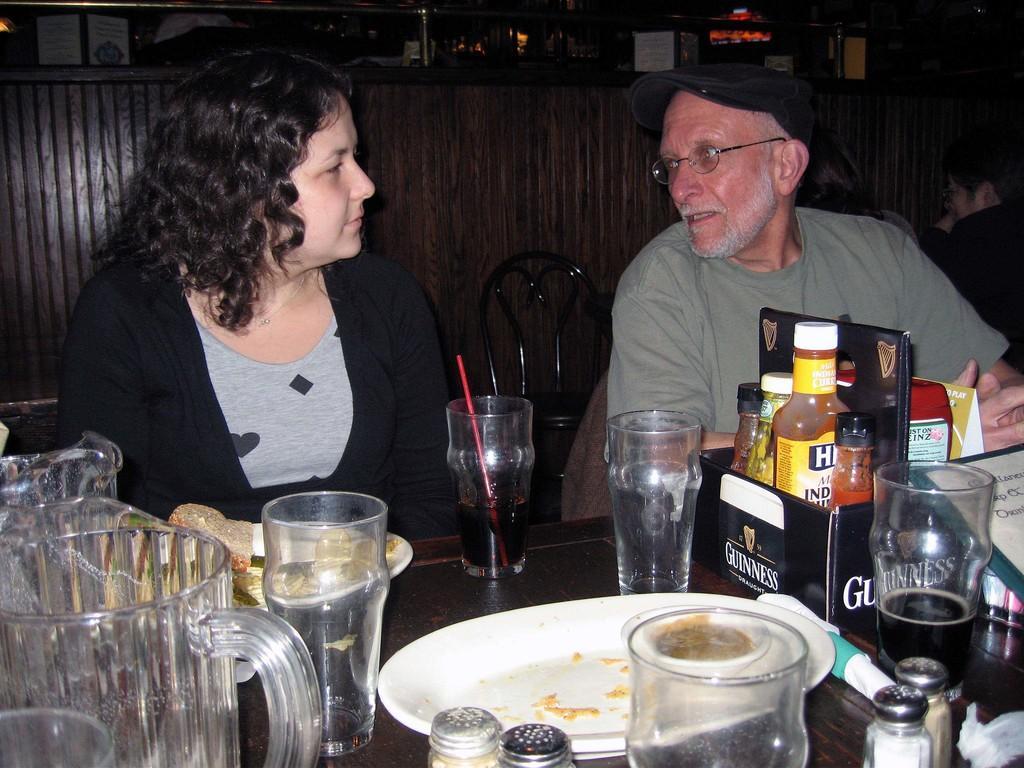Please provide a concise description of this image. In this picture I can see people sitting on the chairs. I can see glasses, jars, plates on the table. 